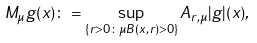<formula> <loc_0><loc_0><loc_500><loc_500>M _ { \mu } g ( x ) \colon = \sup _ { \{ r > 0 \colon \mu B ( x , r ) > 0 \} } A _ { r , \mu } | g | ( x ) ,</formula> 